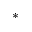Convert formula to latex. <formula><loc_0><loc_0><loc_500><loc_500>\ast</formula> 